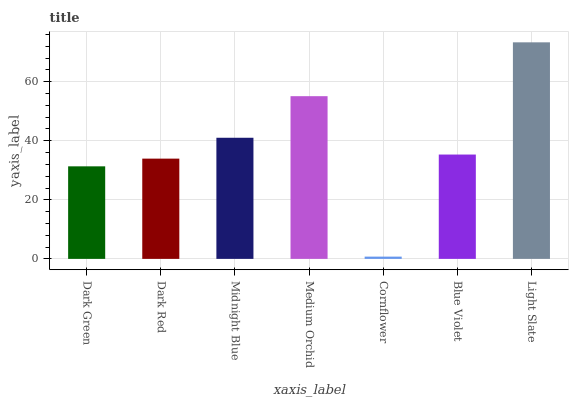Is Cornflower the minimum?
Answer yes or no. Yes. Is Light Slate the maximum?
Answer yes or no. Yes. Is Dark Red the minimum?
Answer yes or no. No. Is Dark Red the maximum?
Answer yes or no. No. Is Dark Red greater than Dark Green?
Answer yes or no. Yes. Is Dark Green less than Dark Red?
Answer yes or no. Yes. Is Dark Green greater than Dark Red?
Answer yes or no. No. Is Dark Red less than Dark Green?
Answer yes or no. No. Is Blue Violet the high median?
Answer yes or no. Yes. Is Blue Violet the low median?
Answer yes or no. Yes. Is Light Slate the high median?
Answer yes or no. No. Is Dark Green the low median?
Answer yes or no. No. 